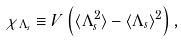<formula> <loc_0><loc_0><loc_500><loc_500>\chi _ { \Lambda _ { s } } \equiv V \left ( \langle \Lambda _ { s } ^ { 2 } \rangle - \langle \Lambda _ { s } \rangle ^ { 2 } \right ) ,</formula> 